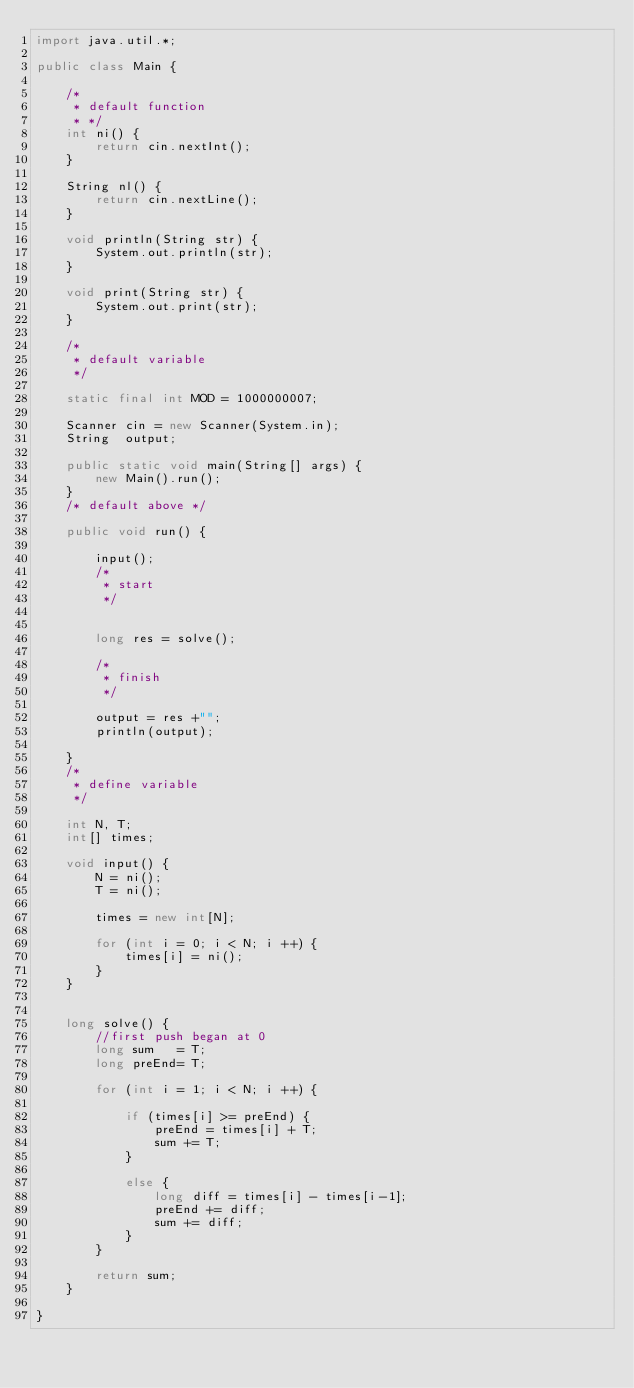<code> <loc_0><loc_0><loc_500><loc_500><_Java_>import java.util.*;

public class Main {
	
	/*
	 * default function
	 * */	
	int ni() {
		return cin.nextInt();
	}
	
	String nl() {
		return cin.nextLine();
	}
	
	void println(String str) {	
		System.out.println(str);
	}
	
	void print(String str) {
		System.out.print(str);
	}
	
	/*
	 * default variable
	 */
	
	static final int MOD = 1000000007;
	
	Scanner cin = new Scanner(System.in);	
	String  output;
	
	public static void main(String[] args) {			
		new Main().run();						
	}
	/* default above */
		
	public void run() {
			
		input();
		/* 
		 * start
		 */	
		
		
		long res = solve();
		
		/*
		 * finish
		 */
		
		output = res +"";
		println(output);
			
	}
	/* 
	 * define variable
	 */
	
	int N, T;
	int[] times;
	
	void input() {
		N = ni();
		T = ni();
		
		times = new int[N];
		
		for (int i = 0; i < N; i ++) {
			times[i] = ni();
		}		
	}
	
	
	long solve() {
		//first push began at 0
		long sum   = T;
		long preEnd= T;
		
		for (int i = 1; i < N; i ++) {
			
			if (times[i] >= preEnd) {
				preEnd = times[i] + T;
				sum += T;
			}
			
			else {
				long diff = times[i] - times[i-1];
				preEnd += diff;
				sum += diff;
			}
		}
		
		return sum;
	}
	
}
</code> 